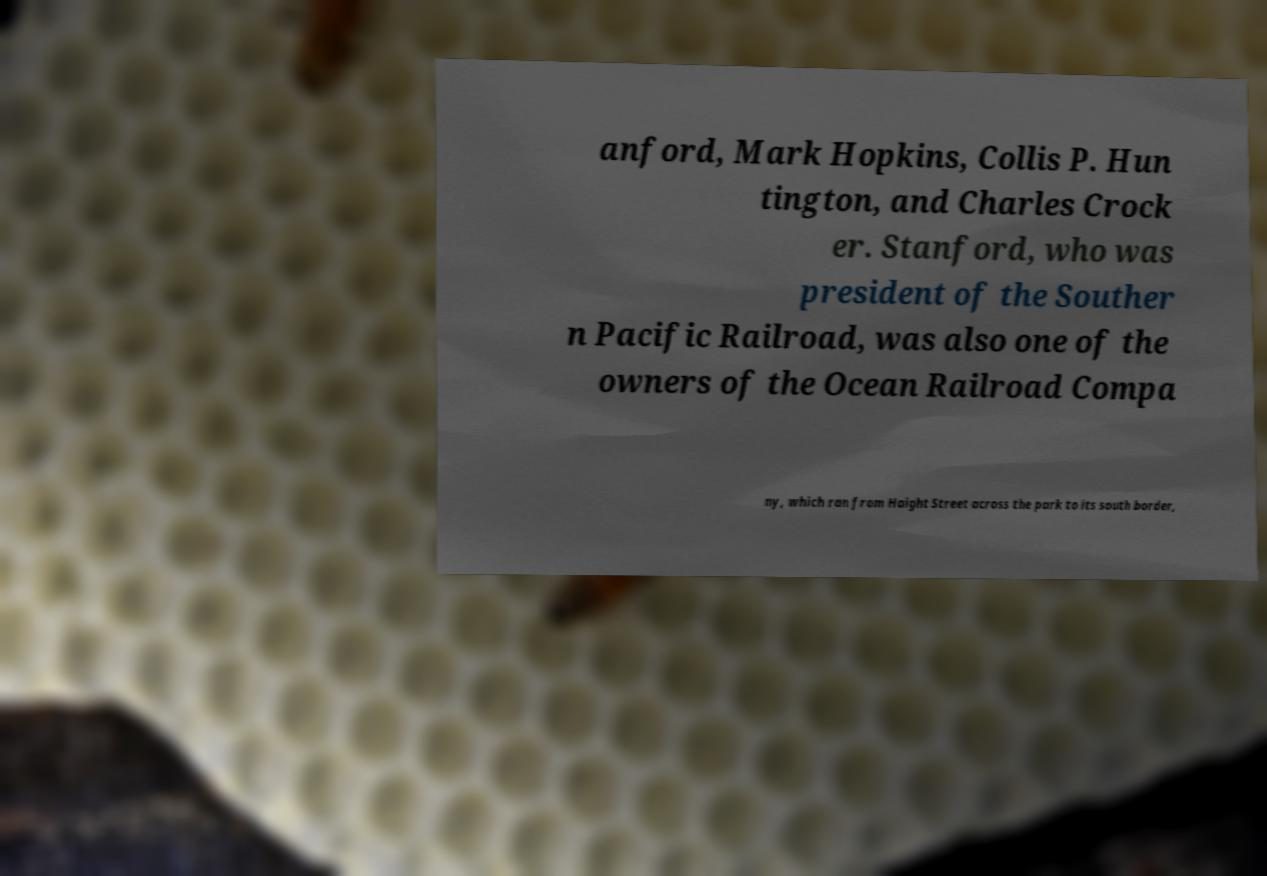Could you assist in decoding the text presented in this image and type it out clearly? anford, Mark Hopkins, Collis P. Hun tington, and Charles Crock er. Stanford, who was president of the Souther n Pacific Railroad, was also one of the owners of the Ocean Railroad Compa ny, which ran from Haight Street across the park to its south border, 